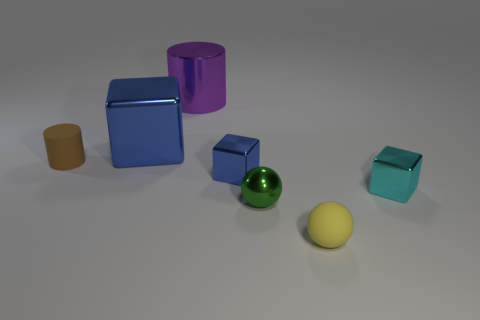Add 2 small metallic things. How many objects exist? 9 Subtract all cylinders. How many objects are left? 5 Subtract all tiny matte cylinders. Subtract all tiny cyan metal blocks. How many objects are left? 5 Add 3 small brown matte cylinders. How many small brown matte cylinders are left? 4 Add 7 cyan shiny spheres. How many cyan shiny spheres exist? 7 Subtract 1 cyan blocks. How many objects are left? 6 